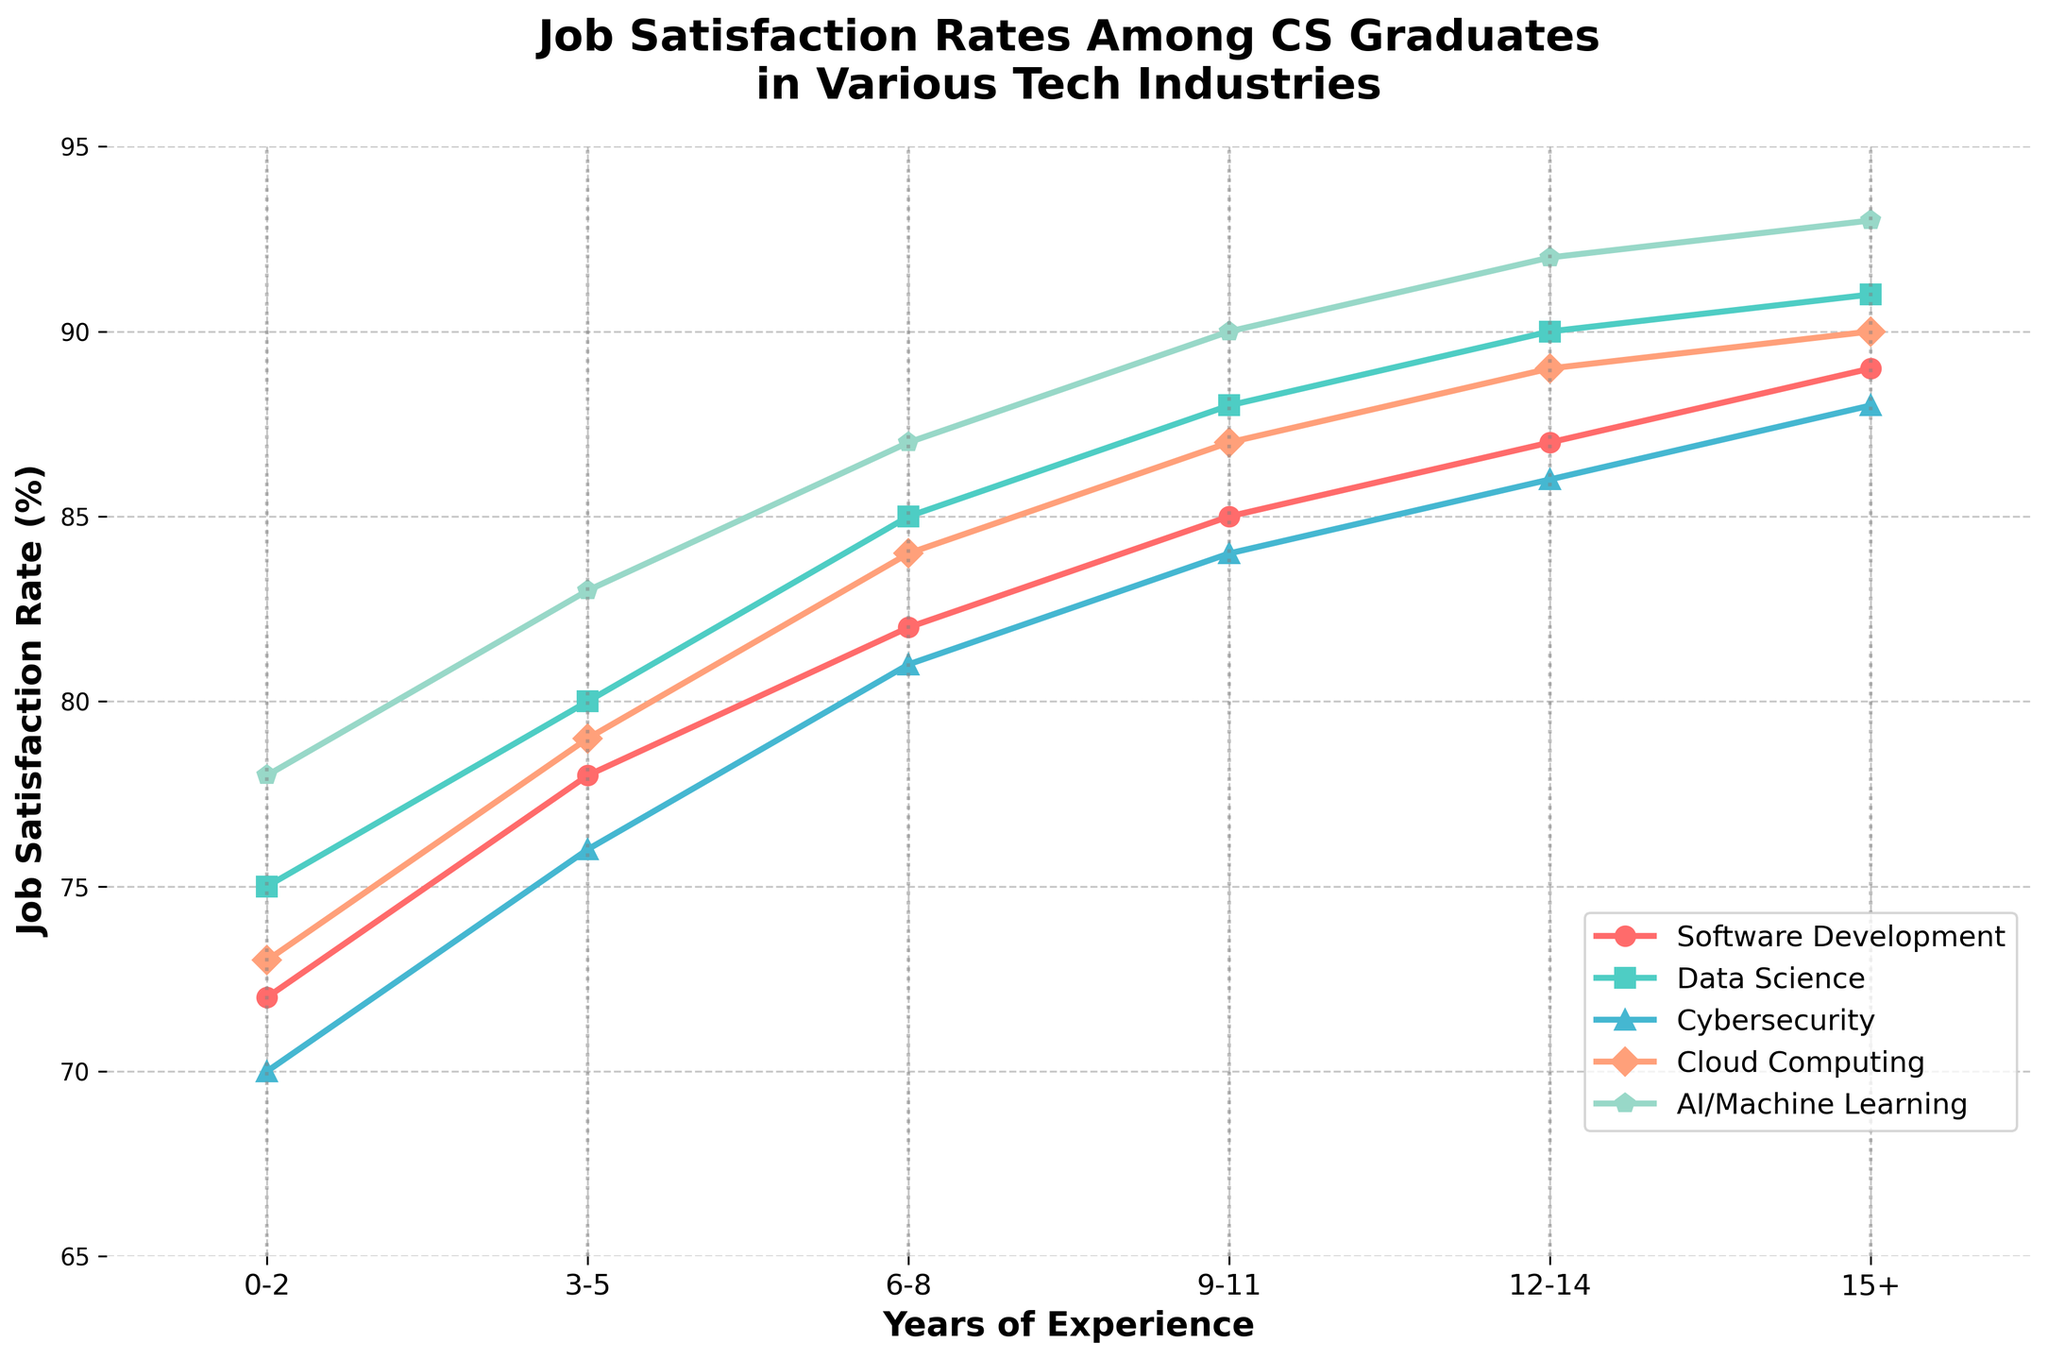What is the job satisfaction rate for AI/Machine Learning professionals with 6-8 years of experience? Looking at the plotted line for AI/Machine Learning (purple colored with a 'p' marker), the y-coordinate corresponding to "6-8" years of experience shows the job satisfaction rate. It is 87%.
Answer: 87% Which industry sees the most significant increase in job satisfaction from 0-2 years to 3-5 years of experience? Calculate the difference for each industry between the job satisfaction rates at 3-5 years and 0-2 years. Software Development: 78-72=6, Data Science: 80-75=5, Cybersecurity: 76-70=6, Cloud Computing: 79-73=6, AI/Machine Learning: 83-78=5. All values are the same, indicating a tie between Software Development, Cybersecurity, Cloud Computing.
Answer: Software Development, Cybersecurity, Cloud Computing What is the average job satisfaction rate of Cybersecurity professionals across all years of experience? Add up the job satisfaction rates for Cybersecurity across all years (70+76+81+84+86+88) and divide by the number of data points (6). The sum is 485, and the average is 485/6 ≈ 80.83.
Answer: 80.83 What is the job satisfaction rate difference between entry-level (0-2 years) and senior-level (15+ years) positions in Software Development? Find the job satisfaction rate for Software Development at 0-2 years and 15+ years. The rates are 72% and 89%, respectively. The difference is 89 - 72 = 17.
Answer: 17 Between Data Science and Cloud Computing, which field has a higher job satisfaction rate for professionals with 9-11 years of experience? Find the job satisfaction rates for both fields at 9-11 years: Data Science (88%) and Cloud Computing (87%). Data Science has a higher rate.
Answer: Data Science Which industry maintains the highest job satisfaction rate as professionals gain experience? Look at the plotted lines and identify the industry with consistently highest job satisfaction rates across all experience levels. AI/Machine Learning has the highest line throughout.
Answer: AI/Machine Learning How does the job satisfaction rate for Cloud Computing change from 6-8 years to 12-14 years of experience? Find the job satisfaction rates for Cloud Computing at 6-8 years (84%) and 12-14 years (89%). The rate increases by 89 - 84 = 5.
Answer: Increases by 5 Among all industries, which has the lowest job satisfaction rate at 0-2 years of experience? Look for the lowest point among all industries at 0-2 years. Cybersecurity has the lowest rate at 70%.
Answer: Cybersecurity What is the total sum of job satisfaction rates at 15+ years of experience across all industries? Find the satisfaction rates for all industries at 15+ years: Software Development (89), Data Science (91), Cybersecurity (88), Cloud Computing (90), AI/Machine Learning (93). The total sum is 89+91+88+90+93=451.
Answer: 451 